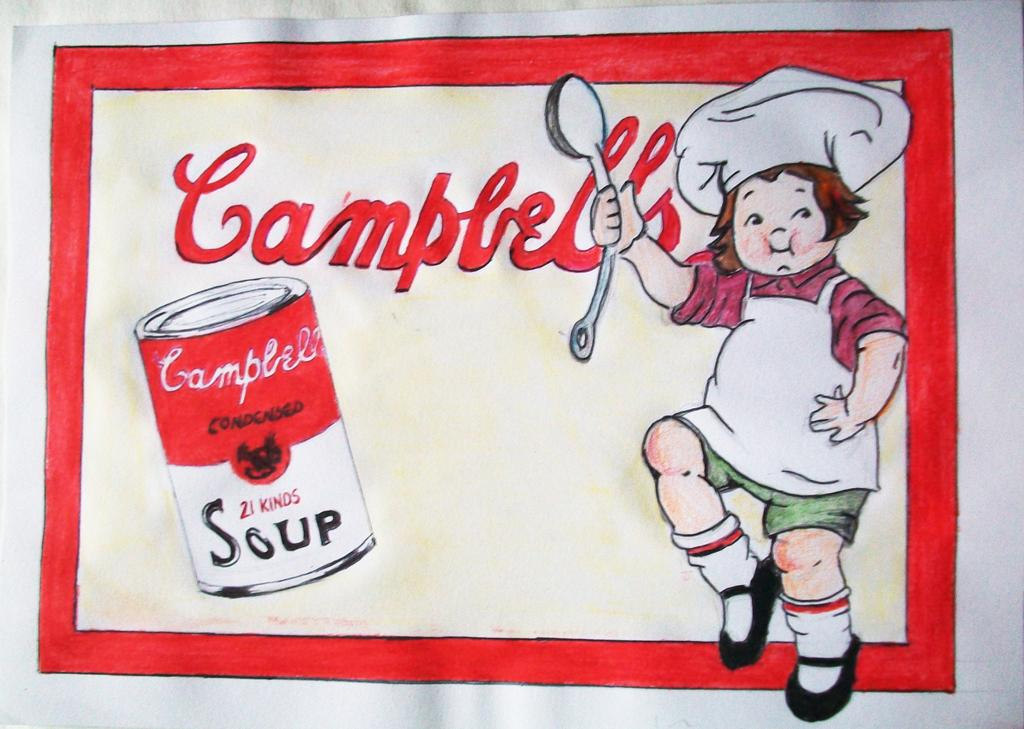What is present in the image? There is a poster in the image. What can be seen in the pictures on the poster? The pictures on the poster show a person holding a spoon and a tin. What else is featured on the poster besides the images? There are letters written on the poster. What type of adjustment does the farmer make to the unit in the image? There is no farmer or unit present in the image; it only features a poster with pictures of a person holding a spoon and a tin, along with letters. 